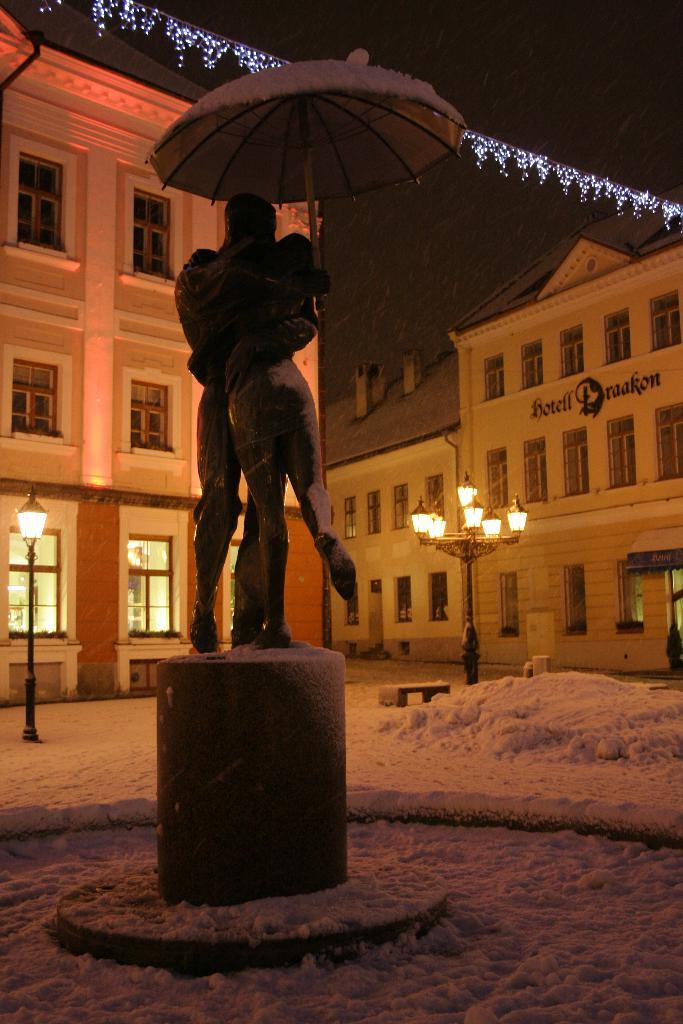What is the main subject in the center of the image? There is a statue in the center of the image. What can be seen in the distance behind the statue? There are buildings, snow, lights, and the sky visible in the background of the image. What is the name of the deer standing next to the statue in the image? There is no deer present in the image; the main subject is a statue. 